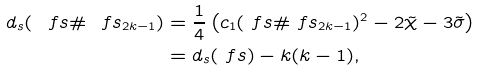<formula> <loc_0><loc_0><loc_500><loc_500>d _ { s } ( \ f s \# \ f s _ { 2 k - 1 } ) & = \frac { 1 } { 4 } \left ( c _ { 1 } ( \ f s \# \ f s _ { 2 k - 1 } ) ^ { 2 } - 2 \tilde { \chi } - 3 \tilde { \sigma } \right ) \\ & = d _ { s } ( \ f s ) - k ( k - 1 ) ,</formula> 